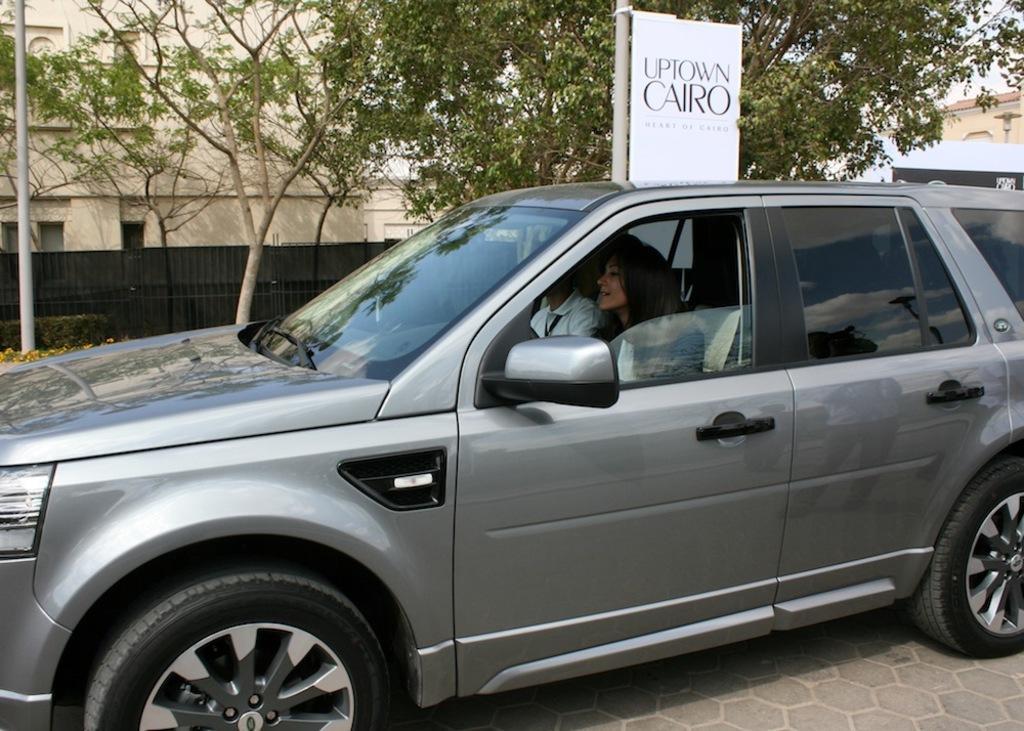Could you give a brief overview of what you see in this image? In this picture we can see man and woman sitting in car and it is on road and in background we can see trees, building, fence, pole, banner. 